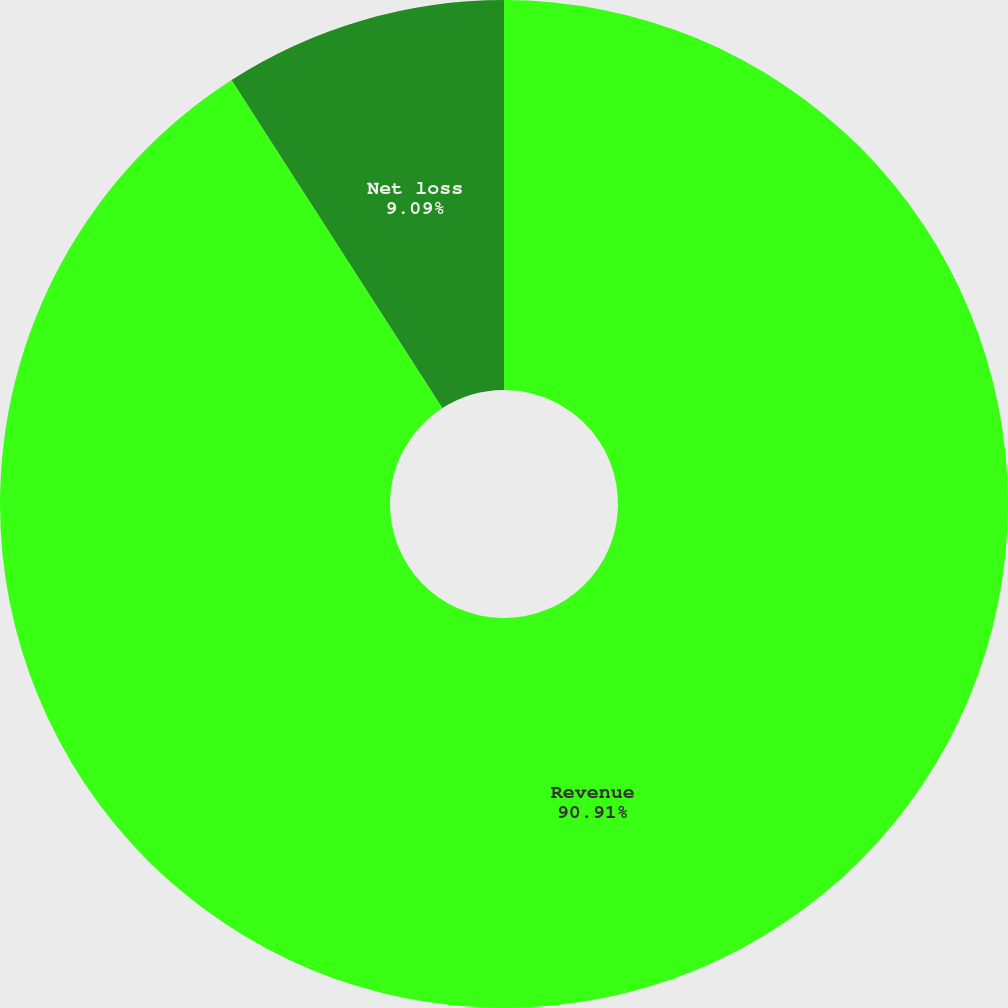Convert chart to OTSL. <chart><loc_0><loc_0><loc_500><loc_500><pie_chart><fcel>Revenue<fcel>Net loss<fcel>Net loss per share basic and<nl><fcel>90.91%<fcel>9.09%<fcel>0.0%<nl></chart> 